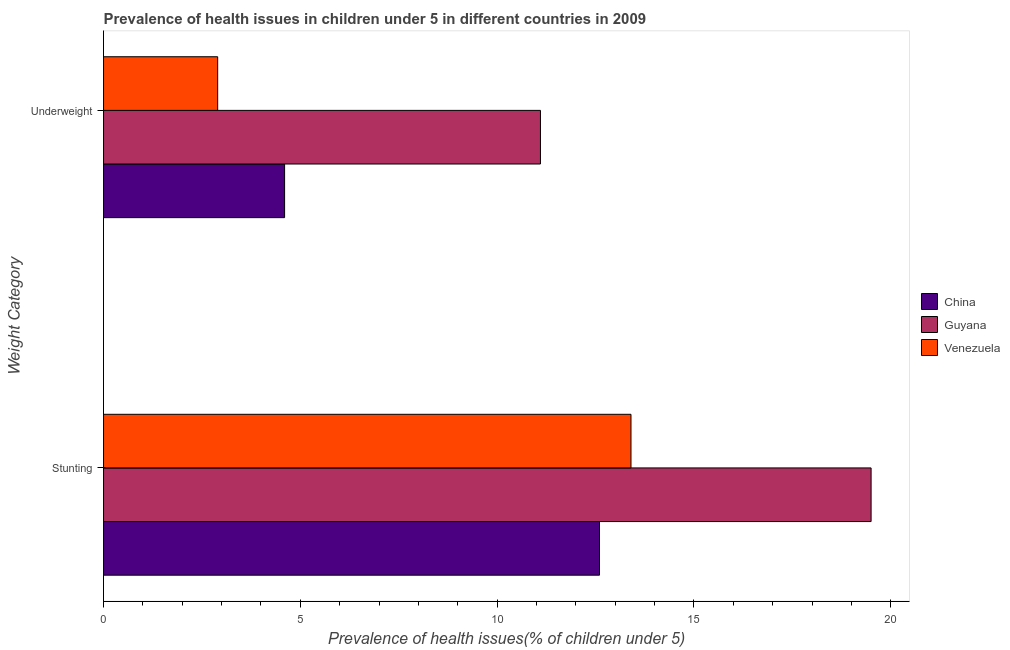How many different coloured bars are there?
Provide a short and direct response. 3. How many groups of bars are there?
Offer a terse response. 2. How many bars are there on the 1st tick from the top?
Ensure brevity in your answer.  3. What is the label of the 2nd group of bars from the top?
Provide a succinct answer. Stunting. What is the percentage of underweight children in Guyana?
Provide a succinct answer. 11.1. Across all countries, what is the maximum percentage of underweight children?
Keep it short and to the point. 11.1. Across all countries, what is the minimum percentage of stunted children?
Your answer should be very brief. 12.6. In which country was the percentage of stunted children maximum?
Offer a very short reply. Guyana. What is the total percentage of stunted children in the graph?
Give a very brief answer. 45.5. What is the difference between the percentage of underweight children in Venezuela and that in Guyana?
Provide a short and direct response. -8.2. What is the difference between the percentage of underweight children in China and the percentage of stunted children in Venezuela?
Make the answer very short. -8.8. What is the average percentage of underweight children per country?
Keep it short and to the point. 6.2. What is the difference between the percentage of stunted children and percentage of underweight children in Venezuela?
Make the answer very short. 10.5. What is the ratio of the percentage of stunted children in Guyana to that in Venezuela?
Offer a very short reply. 1.46. Is the percentage of underweight children in China less than that in Guyana?
Your answer should be compact. Yes. In how many countries, is the percentage of underweight children greater than the average percentage of underweight children taken over all countries?
Offer a very short reply. 1. What does the 3rd bar from the top in Underweight represents?
Give a very brief answer. China. Are all the bars in the graph horizontal?
Give a very brief answer. Yes. What is the difference between two consecutive major ticks on the X-axis?
Your answer should be very brief. 5. Are the values on the major ticks of X-axis written in scientific E-notation?
Provide a short and direct response. No. Does the graph contain any zero values?
Provide a succinct answer. No. Does the graph contain grids?
Your answer should be compact. No. Where does the legend appear in the graph?
Your answer should be very brief. Center right. How are the legend labels stacked?
Your answer should be very brief. Vertical. What is the title of the graph?
Your response must be concise. Prevalence of health issues in children under 5 in different countries in 2009. What is the label or title of the X-axis?
Provide a succinct answer. Prevalence of health issues(% of children under 5). What is the label or title of the Y-axis?
Keep it short and to the point. Weight Category. What is the Prevalence of health issues(% of children under 5) of China in Stunting?
Your answer should be very brief. 12.6. What is the Prevalence of health issues(% of children under 5) in Guyana in Stunting?
Offer a terse response. 19.5. What is the Prevalence of health issues(% of children under 5) in Venezuela in Stunting?
Give a very brief answer. 13.4. What is the Prevalence of health issues(% of children under 5) in China in Underweight?
Your answer should be very brief. 4.6. What is the Prevalence of health issues(% of children under 5) of Guyana in Underweight?
Offer a terse response. 11.1. What is the Prevalence of health issues(% of children under 5) in Venezuela in Underweight?
Offer a very short reply. 2.9. Across all Weight Category, what is the maximum Prevalence of health issues(% of children under 5) of China?
Keep it short and to the point. 12.6. Across all Weight Category, what is the maximum Prevalence of health issues(% of children under 5) of Guyana?
Your answer should be very brief. 19.5. Across all Weight Category, what is the maximum Prevalence of health issues(% of children under 5) of Venezuela?
Your answer should be very brief. 13.4. Across all Weight Category, what is the minimum Prevalence of health issues(% of children under 5) of China?
Keep it short and to the point. 4.6. Across all Weight Category, what is the minimum Prevalence of health issues(% of children under 5) of Guyana?
Your answer should be compact. 11.1. Across all Weight Category, what is the minimum Prevalence of health issues(% of children under 5) of Venezuela?
Ensure brevity in your answer.  2.9. What is the total Prevalence of health issues(% of children under 5) of Guyana in the graph?
Offer a very short reply. 30.6. What is the difference between the Prevalence of health issues(% of children under 5) of Guyana in Stunting and that in Underweight?
Your answer should be compact. 8.4. What is the difference between the Prevalence of health issues(% of children under 5) in China in Stunting and the Prevalence of health issues(% of children under 5) in Guyana in Underweight?
Provide a succinct answer. 1.5. What is the difference between the Prevalence of health issues(% of children under 5) in China in Stunting and the Prevalence of health issues(% of children under 5) in Venezuela in Underweight?
Provide a short and direct response. 9.7. What is the difference between the Prevalence of health issues(% of children under 5) in Guyana in Stunting and the Prevalence of health issues(% of children under 5) in Venezuela in Underweight?
Ensure brevity in your answer.  16.6. What is the average Prevalence of health issues(% of children under 5) of Guyana per Weight Category?
Provide a short and direct response. 15.3. What is the average Prevalence of health issues(% of children under 5) in Venezuela per Weight Category?
Provide a succinct answer. 8.15. What is the difference between the Prevalence of health issues(% of children under 5) in China and Prevalence of health issues(% of children under 5) in Venezuela in Stunting?
Your response must be concise. -0.8. What is the ratio of the Prevalence of health issues(% of children under 5) of China in Stunting to that in Underweight?
Offer a terse response. 2.74. What is the ratio of the Prevalence of health issues(% of children under 5) in Guyana in Stunting to that in Underweight?
Provide a short and direct response. 1.76. What is the ratio of the Prevalence of health issues(% of children under 5) in Venezuela in Stunting to that in Underweight?
Provide a succinct answer. 4.62. What is the difference between the highest and the lowest Prevalence of health issues(% of children under 5) in Guyana?
Provide a short and direct response. 8.4. What is the difference between the highest and the lowest Prevalence of health issues(% of children under 5) in Venezuela?
Your response must be concise. 10.5. 